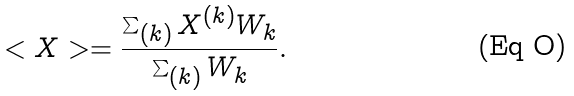Convert formula to latex. <formula><loc_0><loc_0><loc_500><loc_500>< X > = \frac { \sum _ { ( k ) } X ^ { ( k ) } W _ { k } } { \sum _ { ( k ) } W _ { k } } .</formula> 